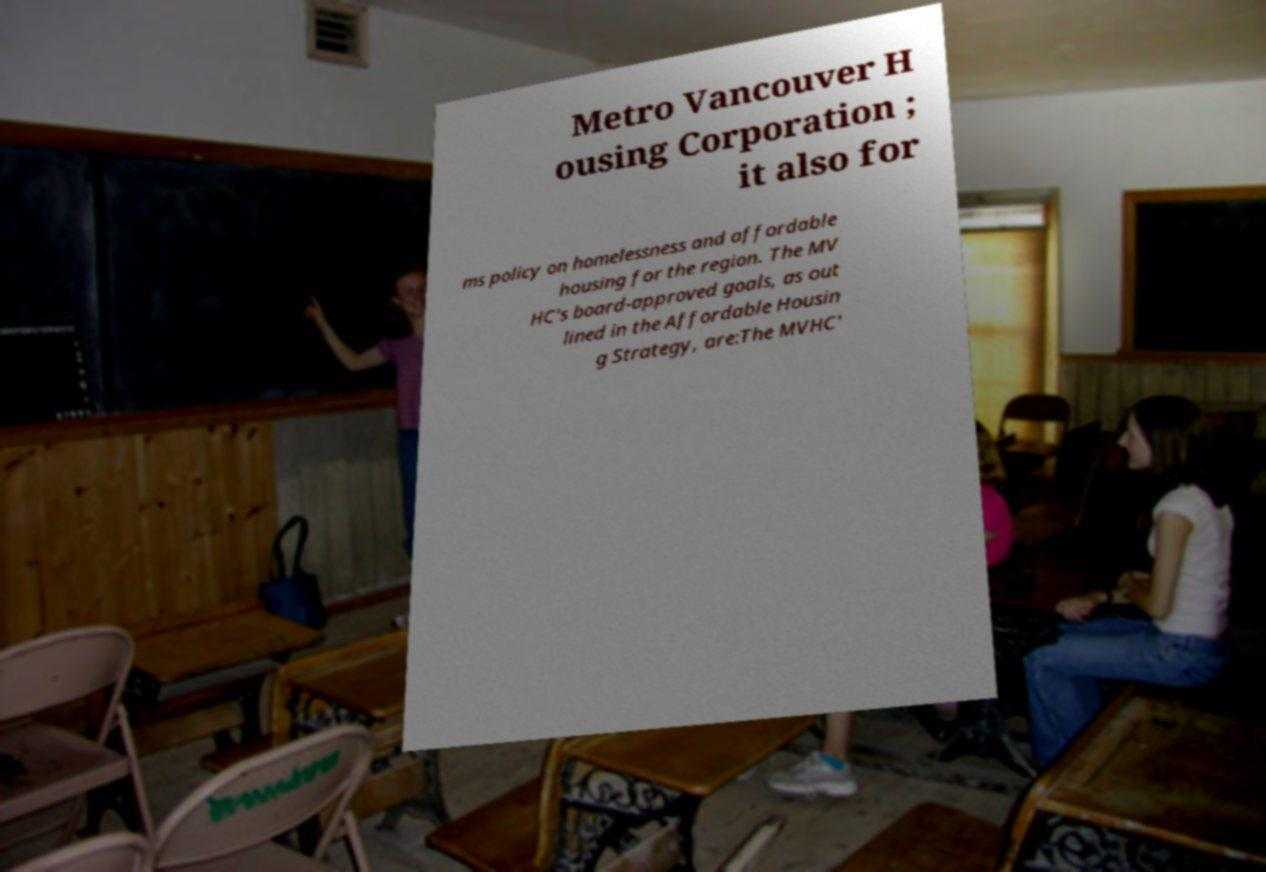I need the written content from this picture converted into text. Can you do that? Metro Vancouver H ousing Corporation ; it also for ms policy on homelessness and affordable housing for the region. The MV HC's board-approved goals, as out lined in the Affordable Housin g Strategy, are:The MVHC' 